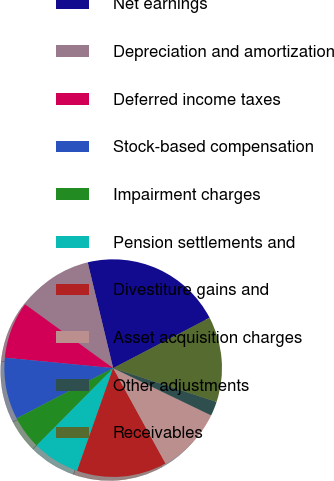<chart> <loc_0><loc_0><loc_500><loc_500><pie_chart><fcel>Net earnings<fcel>Depreciation and amortization<fcel>Deferred income taxes<fcel>Stock-based compensation<fcel>Impairment charges<fcel>Pension settlements and<fcel>Divestiture gains and<fcel>Asset acquisition charges<fcel>Other adjustments<fcel>Receivables<nl><fcel>21.1%<fcel>11.26%<fcel>8.45%<fcel>9.16%<fcel>4.94%<fcel>7.05%<fcel>13.37%<fcel>9.86%<fcel>2.13%<fcel>12.67%<nl></chart> 